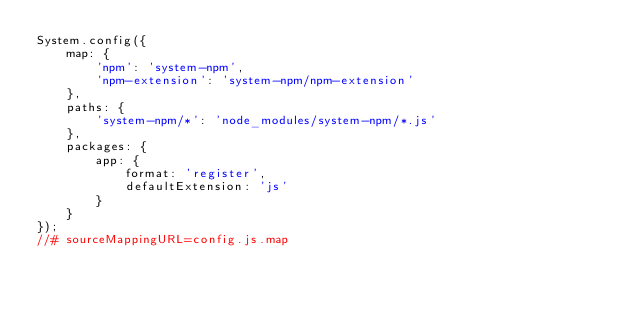Convert code to text. <code><loc_0><loc_0><loc_500><loc_500><_JavaScript_>System.config({
    map: {
        'npm': 'system-npm',
        'npm-extension': 'system-npm/npm-extension'
    },
    paths: {
        'system-npm/*': 'node_modules/system-npm/*.js'
    },
    packages: {
        app: {
            format: 'register',
            defaultExtension: 'js'
        }
    }
});
//# sourceMappingURL=config.js.map</code> 